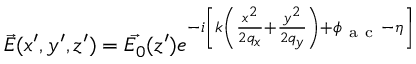Convert formula to latex. <formula><loc_0><loc_0><loc_500><loc_500>\ V e c { E } ( x ^ { \prime } , y ^ { \prime } , z ^ { \prime } ) = \ V e c { E _ { 0 } } ( z ^ { \prime } ) e ^ { - i \left [ k \left ( \frac { x ^ { 2 } } { 2 q _ { x } } + \frac { y ^ { 2 } } { 2 q _ { y } } \right ) + \phi _ { a c } - \eta \right ] }</formula> 